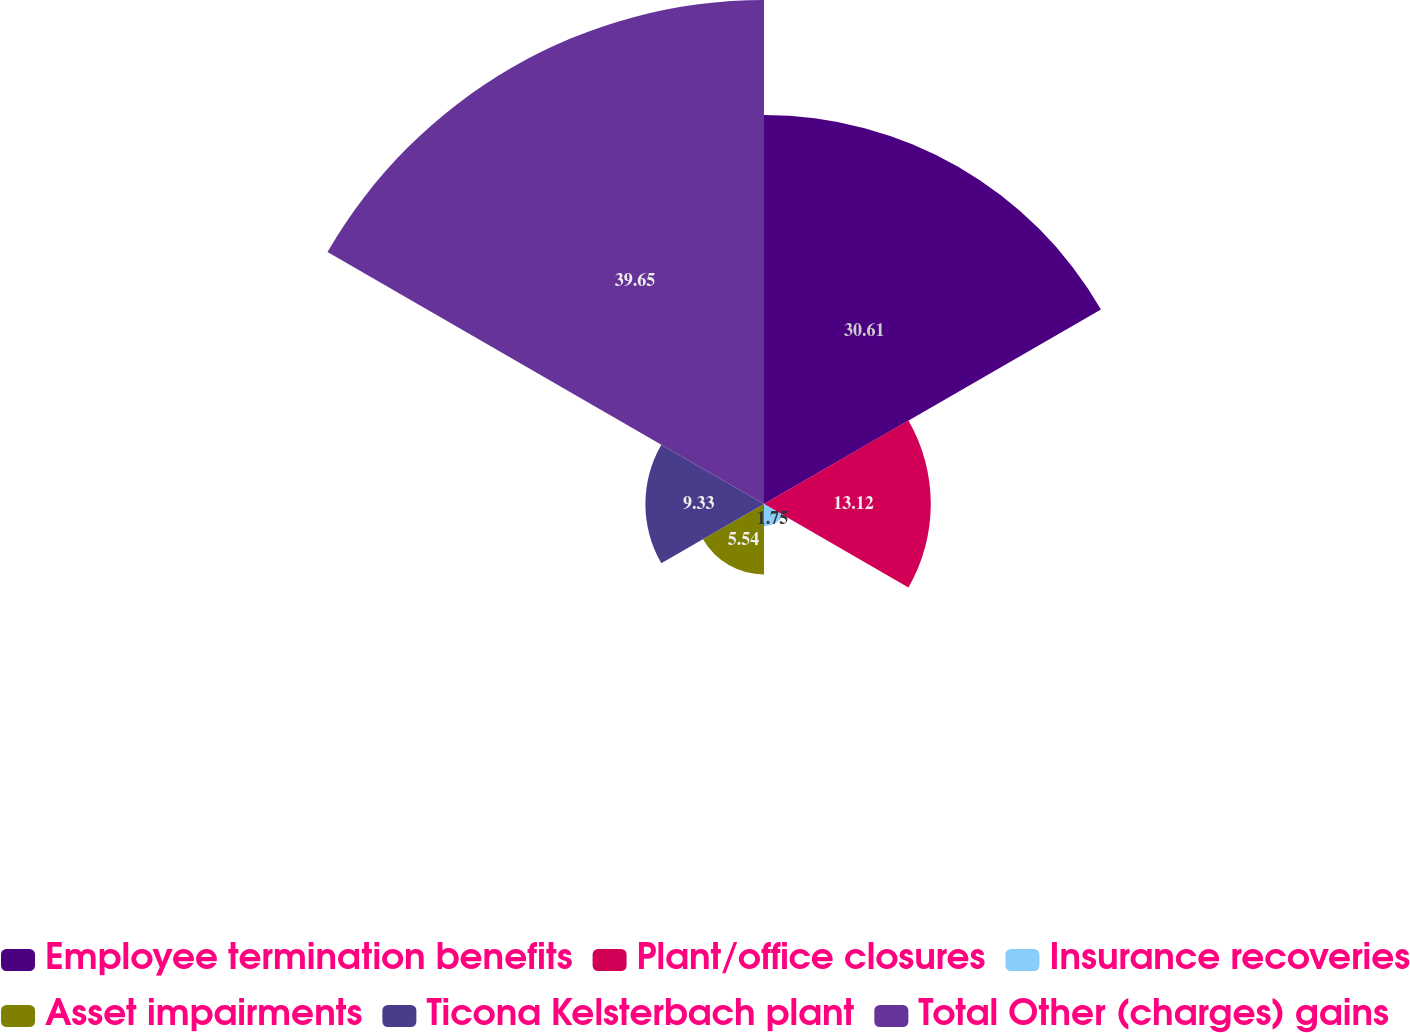<chart> <loc_0><loc_0><loc_500><loc_500><pie_chart><fcel>Employee termination benefits<fcel>Plant/office closures<fcel>Insurance recoveries<fcel>Asset impairments<fcel>Ticona Kelsterbach plant<fcel>Total Other (charges) gains<nl><fcel>30.61%<fcel>13.12%<fcel>1.75%<fcel>5.54%<fcel>9.33%<fcel>39.65%<nl></chart> 